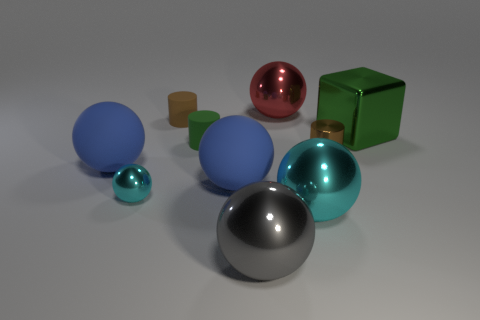The block that is made of the same material as the gray ball is what color?
Make the answer very short. Green. There is a cyan shiny object that is on the right side of the small green cylinder; is it the same shape as the shiny thing in front of the large cyan shiny ball?
Give a very brief answer. Yes. How many metallic objects are tiny cyan blocks or balls?
Your answer should be compact. 4. There is a small object that is the same color as the cube; what material is it?
Give a very brief answer. Rubber. Are there any other things that are the same shape as the large green object?
Ensure brevity in your answer.  No. What is the material of the sphere behind the brown metal object?
Give a very brief answer. Metal. Is the material of the brown cylinder that is behind the large green metal object the same as the green cylinder?
Your answer should be very brief. Yes. What number of things are either tiny green cylinders or metallic things to the right of the brown shiny thing?
Keep it short and to the point. 2. There is a gray thing that is the same shape as the large red metallic object; what size is it?
Make the answer very short. Large. Are there any big blue matte spheres in front of the large gray metallic ball?
Your response must be concise. No. 